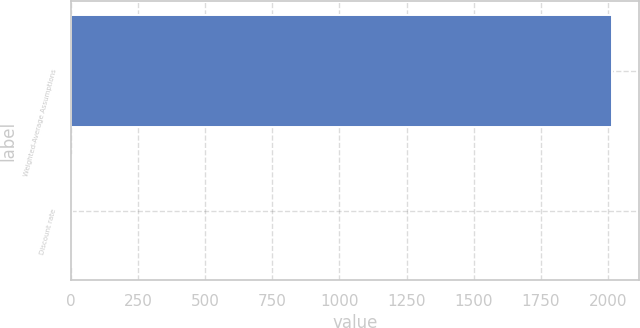Convert chart. <chart><loc_0><loc_0><loc_500><loc_500><bar_chart><fcel>Weighted-Average Assumptions<fcel>Discount rate<nl><fcel>2014<fcel>5.06<nl></chart> 